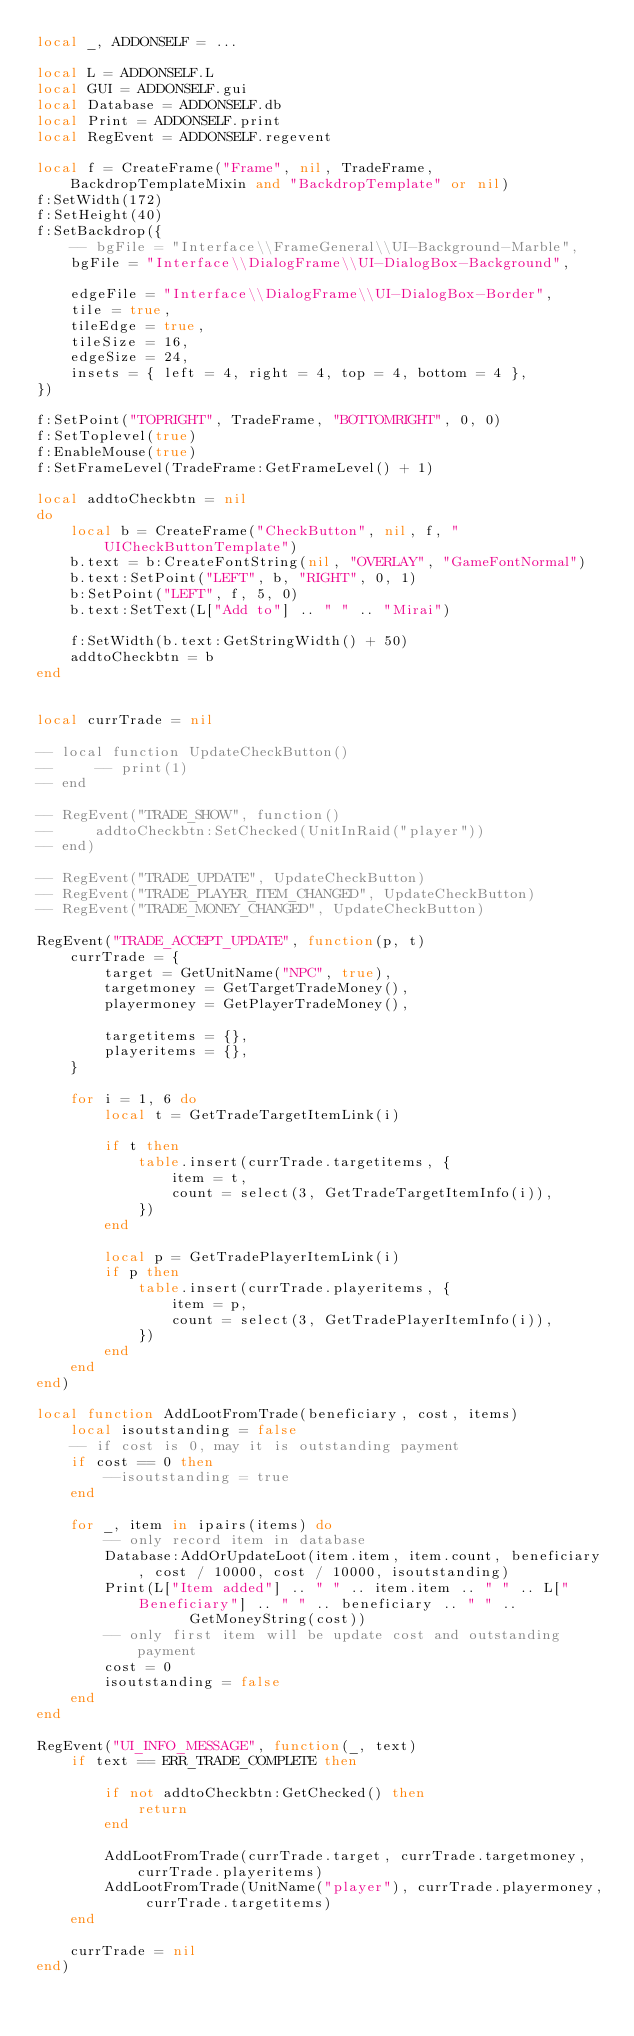<code> <loc_0><loc_0><loc_500><loc_500><_Lua_>local _, ADDONSELF = ...

local L = ADDONSELF.L
local GUI = ADDONSELF.gui
local Database = ADDONSELF.db
local Print = ADDONSELF.print
local RegEvent = ADDONSELF.regevent

local f = CreateFrame("Frame", nil, TradeFrame, BackdropTemplateMixin and "BackdropTemplate" or nil)
f:SetWidth(172)
f:SetHeight(40)
f:SetBackdrop({
    -- bgFile = "Interface\\FrameGeneral\\UI-Background-Marble",
    bgFile = "Interface\\DialogFrame\\UI-DialogBox-Background",

    edgeFile = "Interface\\DialogFrame\\UI-DialogBox-Border",
    tile = true,
    tileEdge = true,
    tileSize = 16,
    edgeSize = 24,
    insets = { left = 4, right = 4, top = 4, bottom = 4 },   
})

f:SetPoint("TOPRIGHT", TradeFrame, "BOTTOMRIGHT", 0, 0)
f:SetToplevel(true)
f:EnableMouse(true)
f:SetFrameLevel(TradeFrame:GetFrameLevel() + 1)

local addtoCheckbtn = nil
do
    local b = CreateFrame("CheckButton", nil, f, "UICheckButtonTemplate")
    b.text = b:CreateFontString(nil, "OVERLAY", "GameFontNormal")
    b.text:SetPoint("LEFT", b, "RIGHT", 0, 1)
    b:SetPoint("LEFT", f, 5, 0)
    b.text:SetText(L["Add to"] .. " " .. "Mirai")

    f:SetWidth(b.text:GetStringWidth() + 50)
    addtoCheckbtn = b
end


local currTrade = nil

-- local function UpdateCheckButton()
--     -- print(1)
-- end

-- RegEvent("TRADE_SHOW", function()
--     addtoCheckbtn:SetChecked(UnitInRaid("player"))
-- end)

-- RegEvent("TRADE_UPDATE", UpdateCheckButton)
-- RegEvent("TRADE_PLAYER_ITEM_CHANGED", UpdateCheckButton)
-- RegEvent("TRADE_MONEY_CHANGED", UpdateCheckButton)

RegEvent("TRADE_ACCEPT_UPDATE", function(p, t)
    currTrade = {
        target = GetUnitName("NPC", true),
        targetmoney = GetTargetTradeMoney(),
        playermoney = GetPlayerTradeMoney(),

        targetitems = {},
        playeritems = {},
    }

    for i = 1, 6 do
        local t = GetTradeTargetItemLink(i)

        if t then
            table.insert(currTrade.targetitems, {
                item = t,
                count = select(3, GetTradeTargetItemInfo(i)),
            })
        end
        
        local p = GetTradePlayerItemLink(i)
        if p then
            table.insert(currTrade.playeritems, {
                item = p,
                count = select(3, GetTradePlayerItemInfo(i)),
            })
        end
    end
end)

local function AddLootFromTrade(beneficiary, cost, items)
    local isoutstanding = false
    -- if cost is 0, may it is outstanding payment
    if cost == 0 then
        --isoutstanding = true
    end

    for _, item in ipairs(items) do
        -- only record item in database
        Database:AddOrUpdateLoot(item.item, item.count, beneficiary, cost / 10000, cost / 10000, isoutstanding)
        Print(L["Item added"] .. " " .. item.item .. " " .. L["Beneficiary"] .. " " .. beneficiary .. " " ..
                  GetMoneyString(cost))
        -- only first item will be update cost and outstanding payment
        cost = 0
        isoutstanding = false
    end
end

RegEvent("UI_INFO_MESSAGE", function(_, text)
    if text == ERR_TRADE_COMPLETE then

        if not addtoCheckbtn:GetChecked() then
            return
        end

        AddLootFromTrade(currTrade.target, currTrade.targetmoney, currTrade.playeritems)
        AddLootFromTrade(UnitName("player"), currTrade.playermoney, currTrade.targetitems)
    end

    currTrade = nil
end)
</code> 